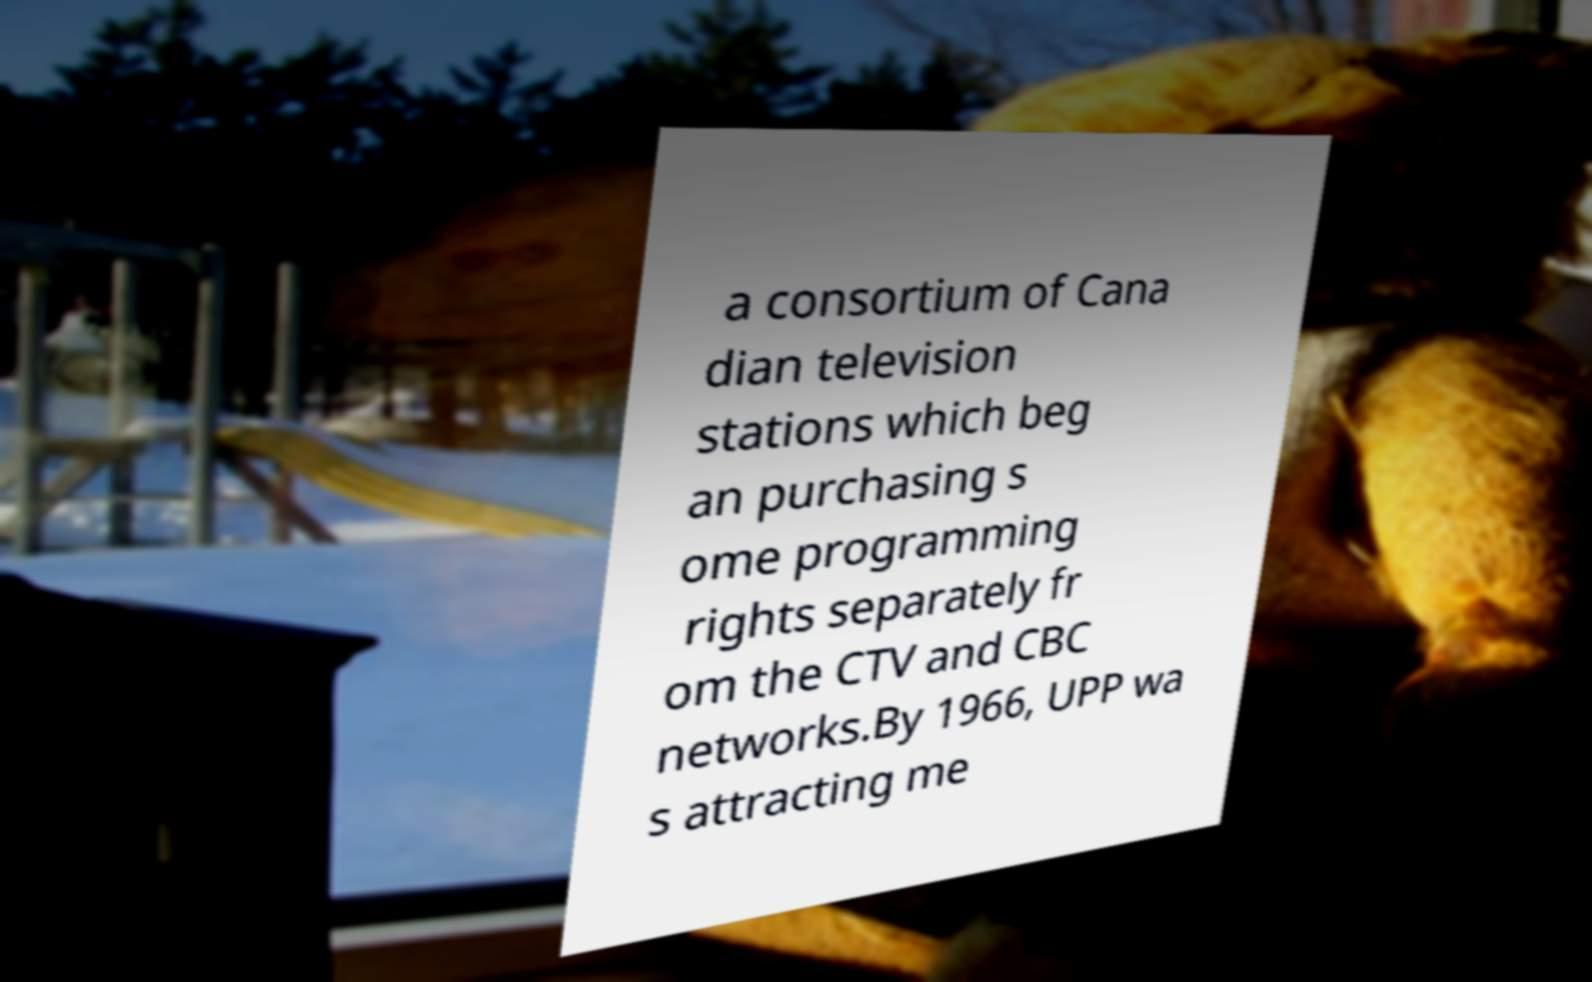Could you assist in decoding the text presented in this image and type it out clearly? a consortium of Cana dian television stations which beg an purchasing s ome programming rights separately fr om the CTV and CBC networks.By 1966, UPP wa s attracting me 